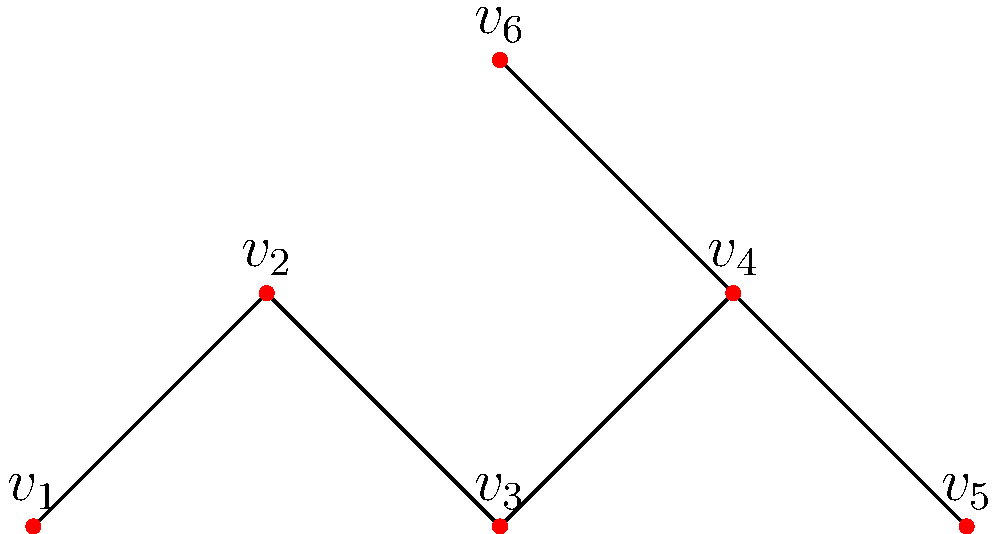In the given undirected graph, how many connected components are there? Explain your reasoning. To determine the number of connected components in an undirected graph, we need to identify groups of vertices that are connected to each other but not to vertices in other groups. Let's analyze this step-by-step:

1. Start with vertex $v_1$:
   - $v_1$ is connected to $v_2$
   - $v_2$ is connected to $v_3$
   - $v_3$ is connected to $v_4$
   So, vertices $v_1$, $v_2$, $v_3$, and $v_4$ form one connected component.

2. Look at the remaining vertices:
   - $v_5$ is connected to $v_6$
   These two vertices form another connected component.

3. Check if there are any isolated vertices:
   - There are no isolated vertices in this graph.

4. Count the number of identified components:
   - We found two separate groups of connected vertices.

Therefore, this undirected graph has 2 connected components:
1. The component containing vertices $v_1$, $v_2$, $v_3$, and $v_4$
2. The component containing vertices $v_5$ and $v_6$
Answer: 2 